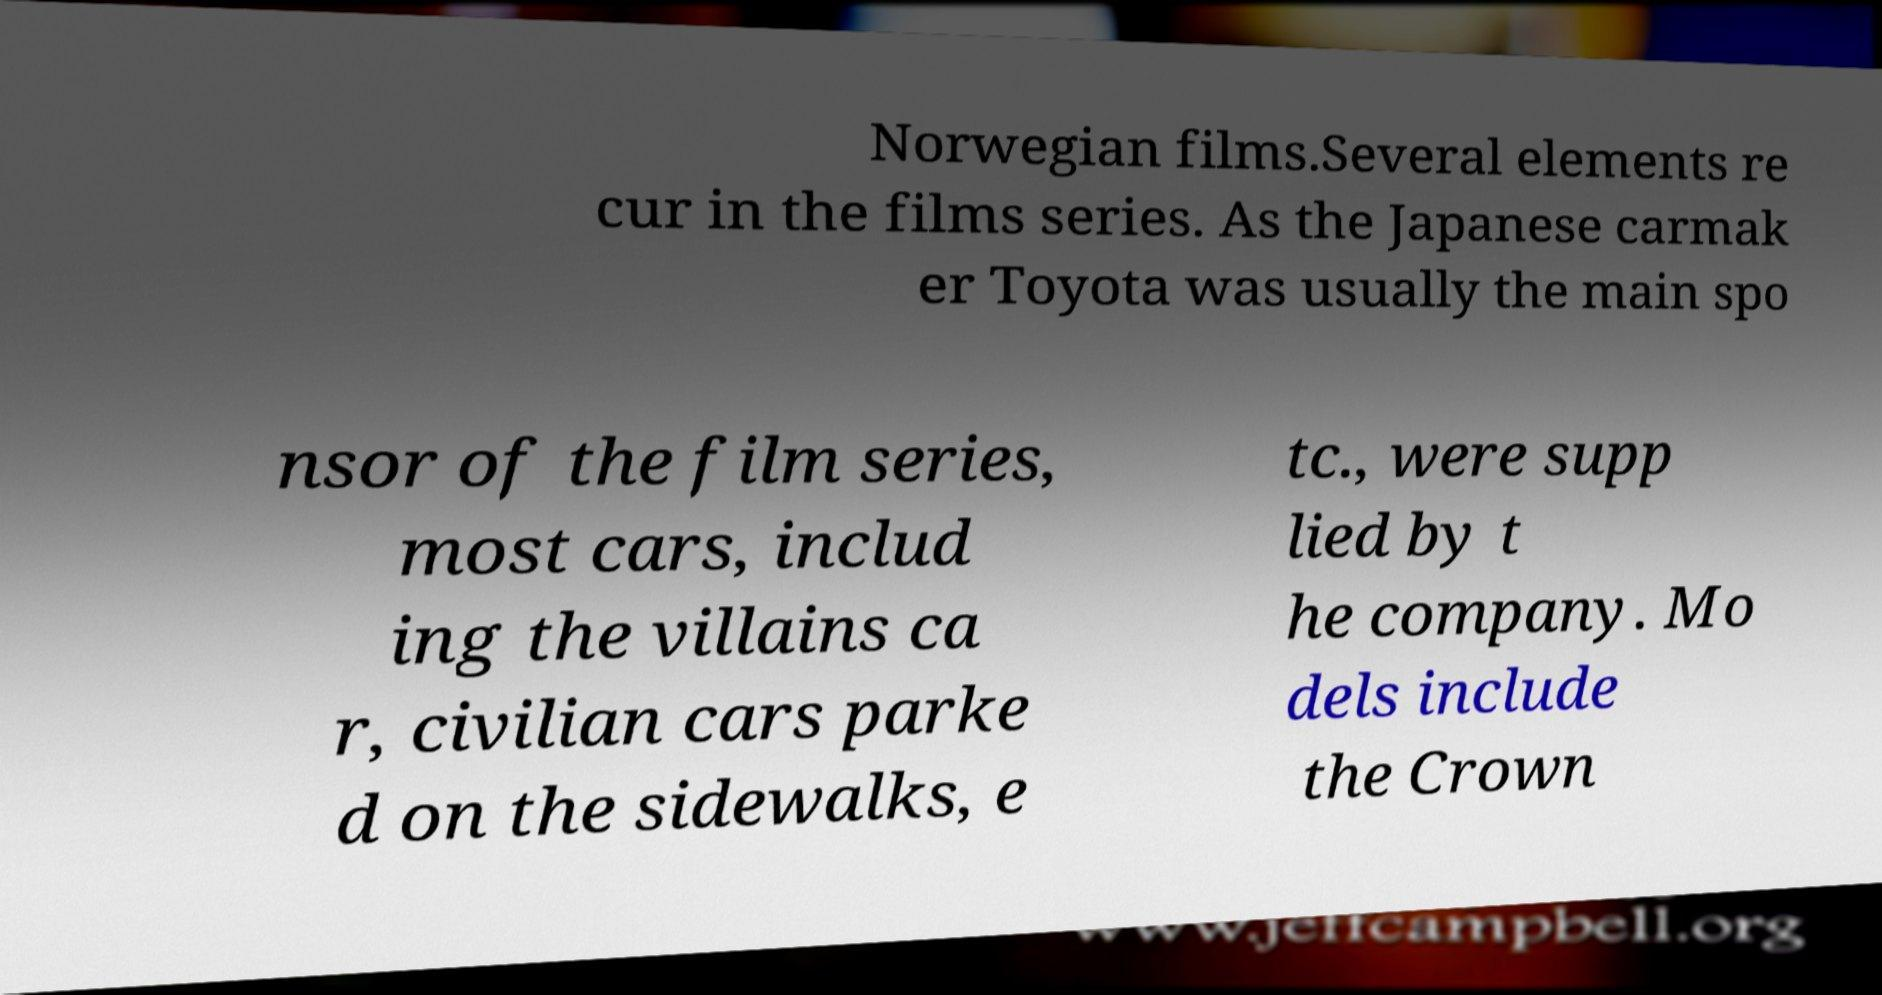Please identify and transcribe the text found in this image. Norwegian films.Several elements re cur in the films series. As the Japanese carmak er Toyota was usually the main spo nsor of the film series, most cars, includ ing the villains ca r, civilian cars parke d on the sidewalks, e tc., were supp lied by t he company. Mo dels include the Crown 